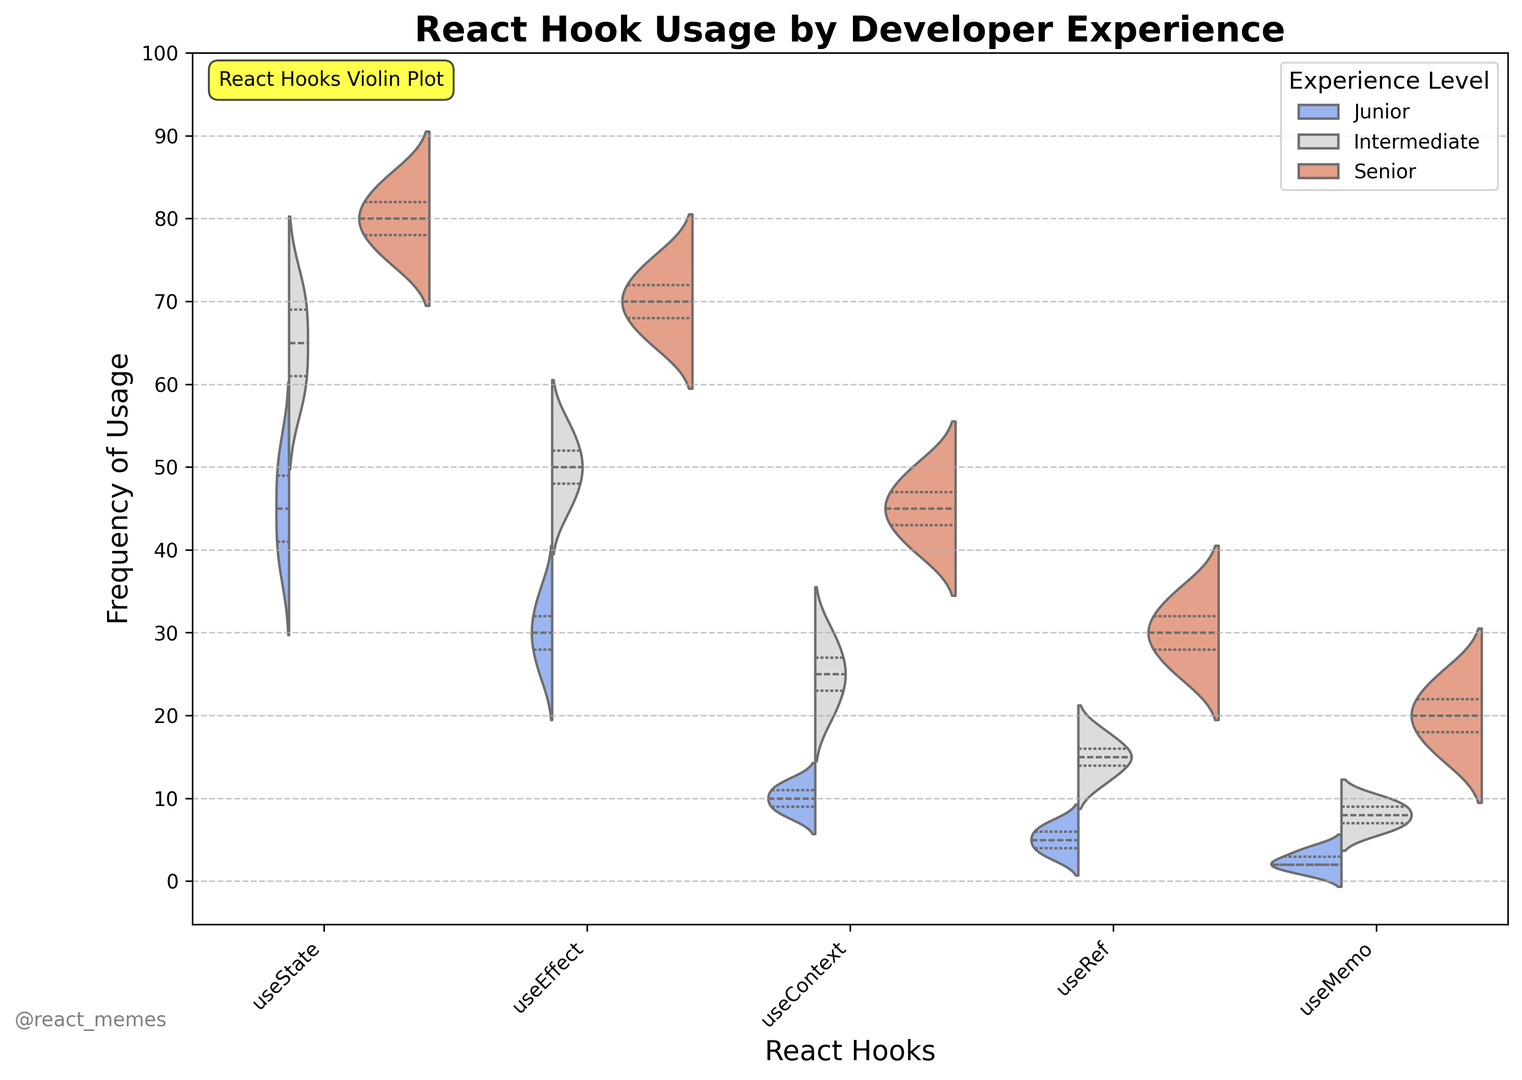What's the frequency range of `useState` usage among Senior developers? The frequency range is determined by identifying the lowest and highest points of the violin plot for `useState` among Senior developers. This range can visually be seen where the density of the Senior category extends from the lowest to highest.
Answer: 75-85 Which React hook is used least frequently by Junior developers? Looking at the violin plots, identify the hook with the lowest frequency values for Junior developers, which can be seen from the lower density distributions. `useMemo` has the lowest frequency values among Junior developers.
Answer: useMemo How do the frequency distributions of `useEffect` differ between Junior and Senior developers? To compare, evaluate the width and position of the violin plots for `useEffect` between Junior and Senior. The plot for Juniors shows lower frequencies ranging around 25-35, while for Seniors, it shows frequencies around 65-75, indicating more frequent usage by Seniors.
Answer: Seniors use it more frequently than Juniors Which experience level has the highest median frequency for `useContext`? Medians can be inferred from the white dots in the violin plots. For `useContext`, visually check each plot and identify the level where the median (white dot) is the highest. Senior developers have the highest median for `useContext`.
Answer: Senior What's the average frequency of `useRef` usage by Intermediate developers? Find the horizontal position of the center line within the `useRef` violin plot for Intermediate developers. This corresponds to the average frequency they use `useRef`, located approximately around the middle density.
Answer: 15 How does the spread of `useState` usage by Junior, Intermediate, and Senior developers compare? Compare the widths and positions of the `useState` violin plots. Juniors show a spread around 38-52, Intermediates around 58-72, and Seniors around 75-85, indicating increasing frequency spread with experience level.
Answer: Spreads increase from Junior to Senior Which React hook shows the highest variation in frequency of usage among Intermediate developers? Variation is indicated by the width of the violin plot. The wider the plot, the higher the variation in the data. For Intermediate developers, `useState` appears to have the widest plot, indicating the highest variation.
Answer: useState Is there a noticeable difference in the frequency distributions of `useMemo` usage between Intermediate and Senior developers? Compare the two violin plots for `useMemo` between Intermediate and Senior developers visually. Both Intermediate and Senior developers show higher frequencies, with Seniors having slightly wider variability.
Answer: Seniors show greater variation Which experience level shows the least variation in frequency of `useEffect` usage? Find the experience level with the narrowest `useEffect` violin plot. The narrower the plot, the less variation in frequency. Junior developers show the least variation with a narrower plot for `useEffect`.
Answer: Junior 